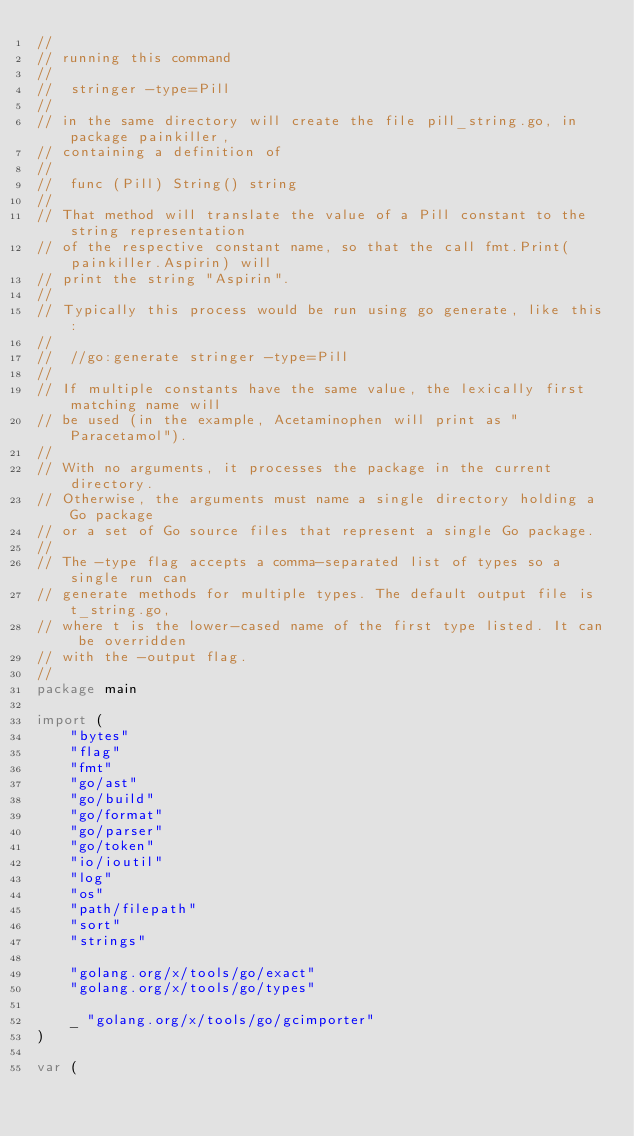<code> <loc_0><loc_0><loc_500><loc_500><_Go_>//
// running this command
//
//	stringer -type=Pill
//
// in the same directory will create the file pill_string.go, in package painkiller,
// containing a definition of
//
//	func (Pill) String() string
//
// That method will translate the value of a Pill constant to the string representation
// of the respective constant name, so that the call fmt.Print(painkiller.Aspirin) will
// print the string "Aspirin".
//
// Typically this process would be run using go generate, like this:
//
//	//go:generate stringer -type=Pill
//
// If multiple constants have the same value, the lexically first matching name will
// be used (in the example, Acetaminophen will print as "Paracetamol").
//
// With no arguments, it processes the package in the current directory.
// Otherwise, the arguments must name a single directory holding a Go package
// or a set of Go source files that represent a single Go package.
//
// The -type flag accepts a comma-separated list of types so a single run can
// generate methods for multiple types. The default output file is t_string.go,
// where t is the lower-cased name of the first type listed. It can be overridden
// with the -output flag.
//
package main

import (
	"bytes"
	"flag"
	"fmt"
	"go/ast"
	"go/build"
	"go/format"
	"go/parser"
	"go/token"
	"io/ioutil"
	"log"
	"os"
	"path/filepath"
	"sort"
	"strings"

	"golang.org/x/tools/go/exact"
	"golang.org/x/tools/go/types"

	_ "golang.org/x/tools/go/gcimporter"
)

var (</code> 